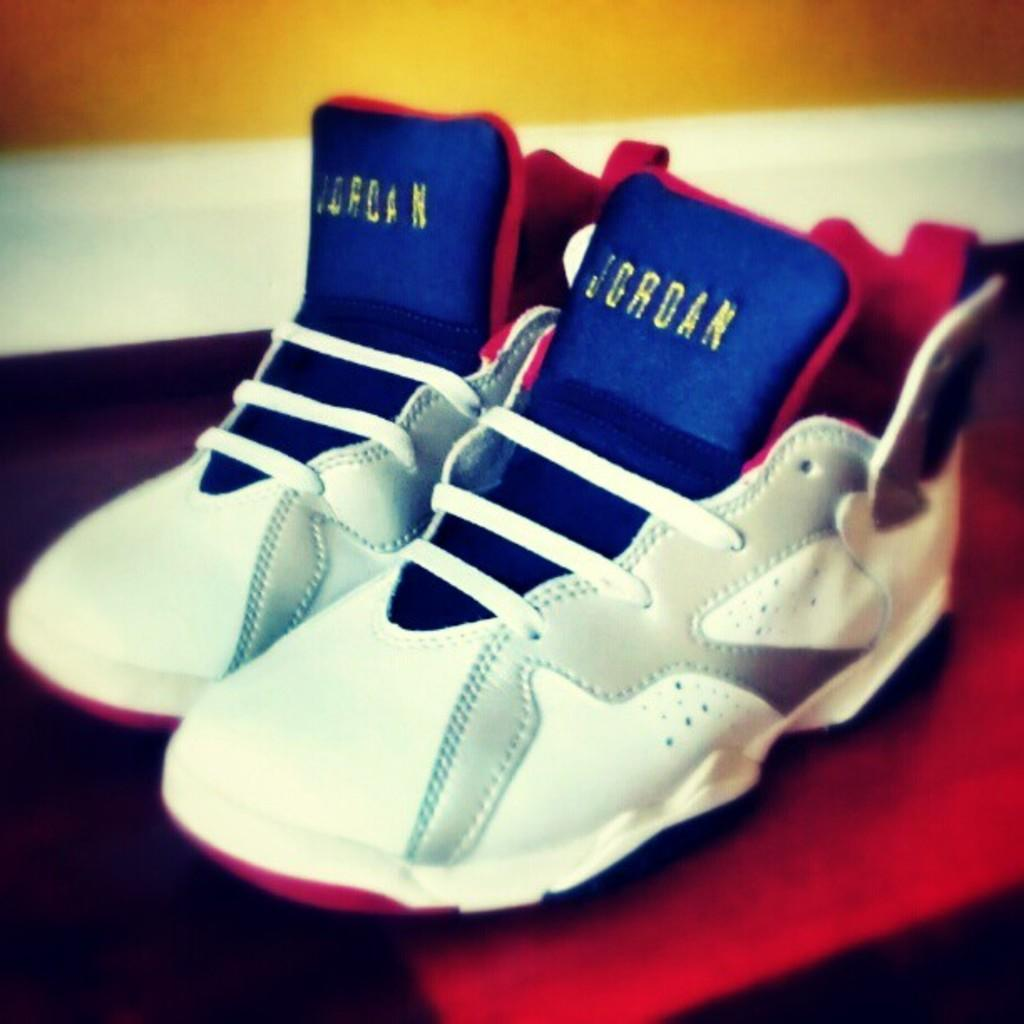What objects are in the image? There are two shoes in the image. Where are the shoes located? The shoes are kept on a table. How are the shoes arranged on the table? The shoes are placed beside each other. What can be seen in the background of the image? There is a wall in the background of the image. What type of apparatus is used to clean the shoes in the image? There is no apparatus visible in the image for cleaning the shoes. Is there a locket hanging from the wall in the image? There is no locket visible in the image; only the shoes and the wall are present. 